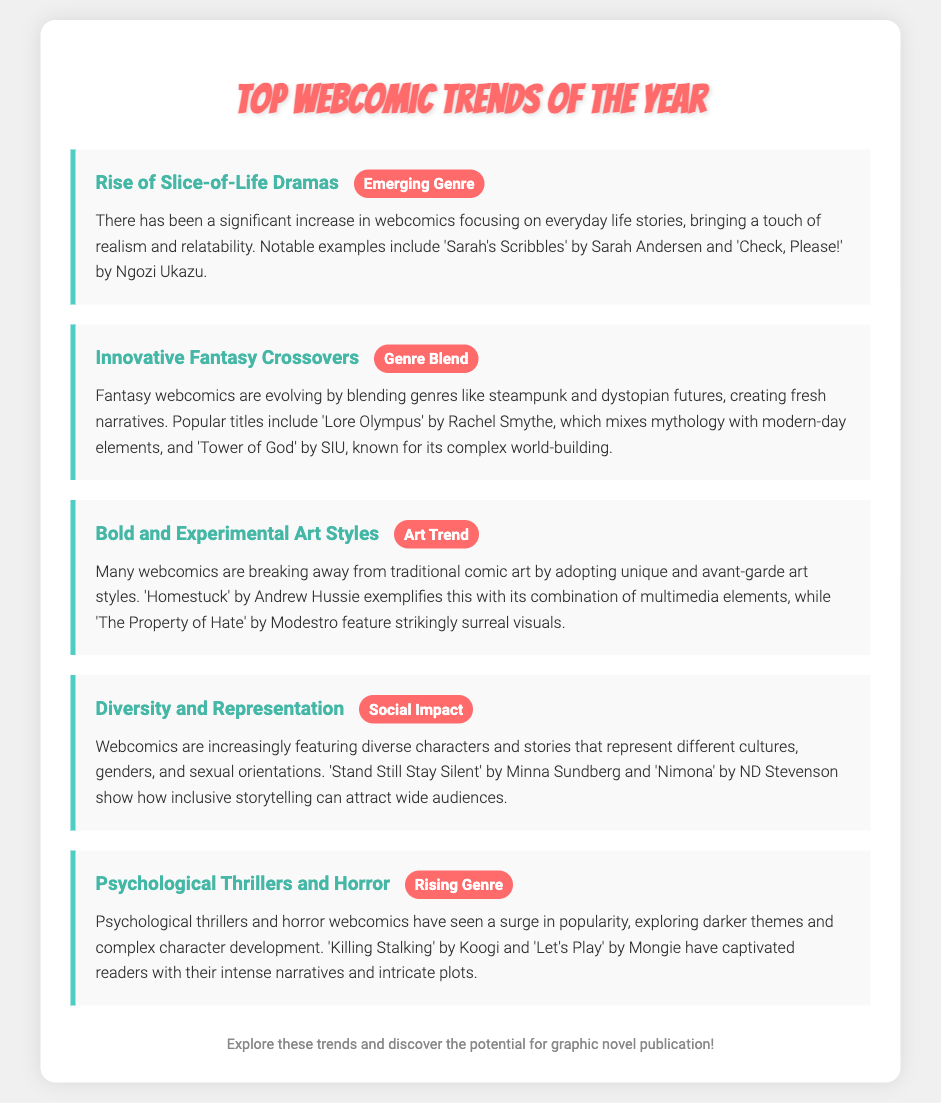What is an emerging genre in webcomics? The document mentions "Slice-of-Life Dramas" as an emerging genre, showcasing stories rooted in everyday experiences.
Answer: Slice-of-Life Dramas What is a notable example of an innovative fantasy crossover webcomic? The document references "Lore Olympus" as a popular title that mixes mythology with modern elements.
Answer: Lore Olympus Which webcomic is known for its bold and experimental art style? The document highlights "Homestuck" as an example of avant-garde art within webcomics.
Answer: Homestuck What is a rising genre in webcomics mentioned in the document? The document points out "Psychological Thrillers and Horror" as a genre that has gained popularity.
Answer: Psychological Thrillers and Horror Which webcomic advocates for diversity and representation? The document lists "Nimona" as a webcomic that showcases inclusive storytelling with diverse characters.
Answer: Nimona How many trends are listed in the document? The document provides a total of five different trends in webcomics for the year.
Answer: Five Which trend focuses on social impact in webcomics? The document identifies "Diversity and Representation" as the trend related to social impact.
Answer: Diversity and Representation What type of art trend is mentioned alongside webcomic titles? The document describes “Bold and Experimental Art Styles” as the type of art trend among webcomics.
Answer: Bold and Experimental Art Styles 